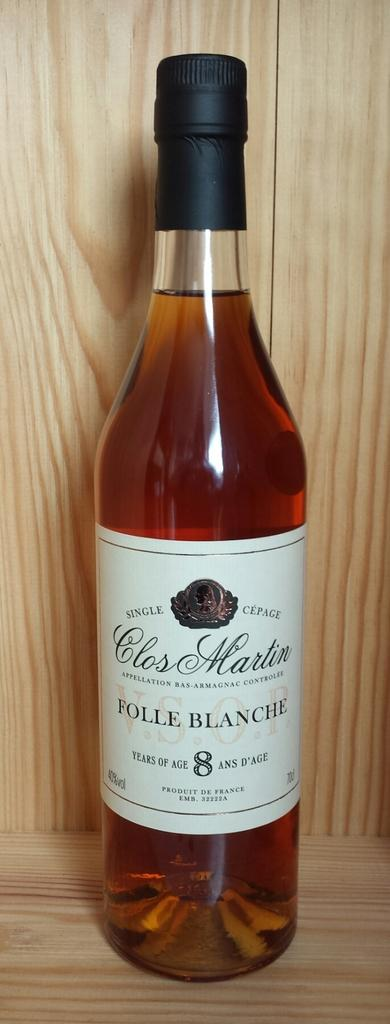<image>
Write a terse but informative summary of the picture. A bottle of 8 year old Folle Blanche by Clos Martin is displayed on wood. 